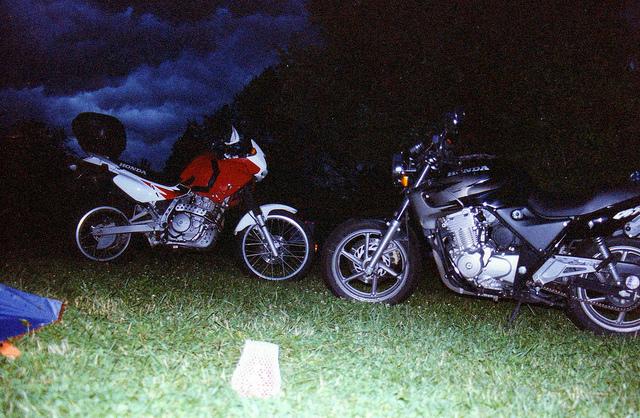What is just out of frame on the left with one blue corner showing?
Write a very short answer. Tent. Is it daytime?
Give a very brief answer. No. Are these harleys?
Short answer required. No. 